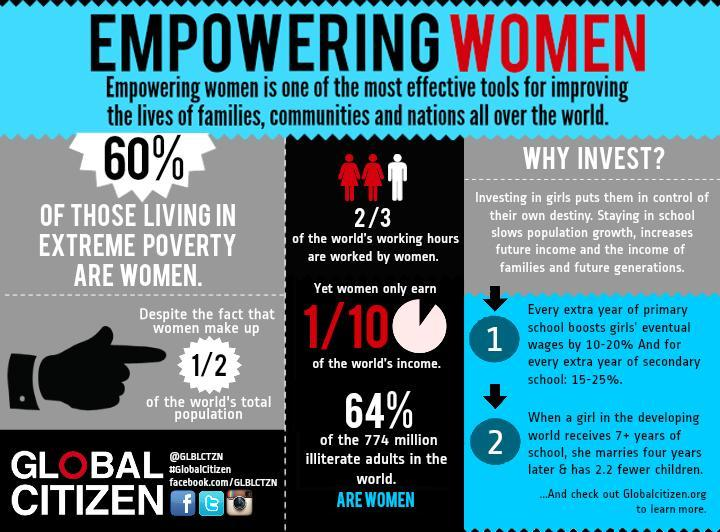What is the hashtag given?
Answer the question with a short phrase. #GlobalCitizen 